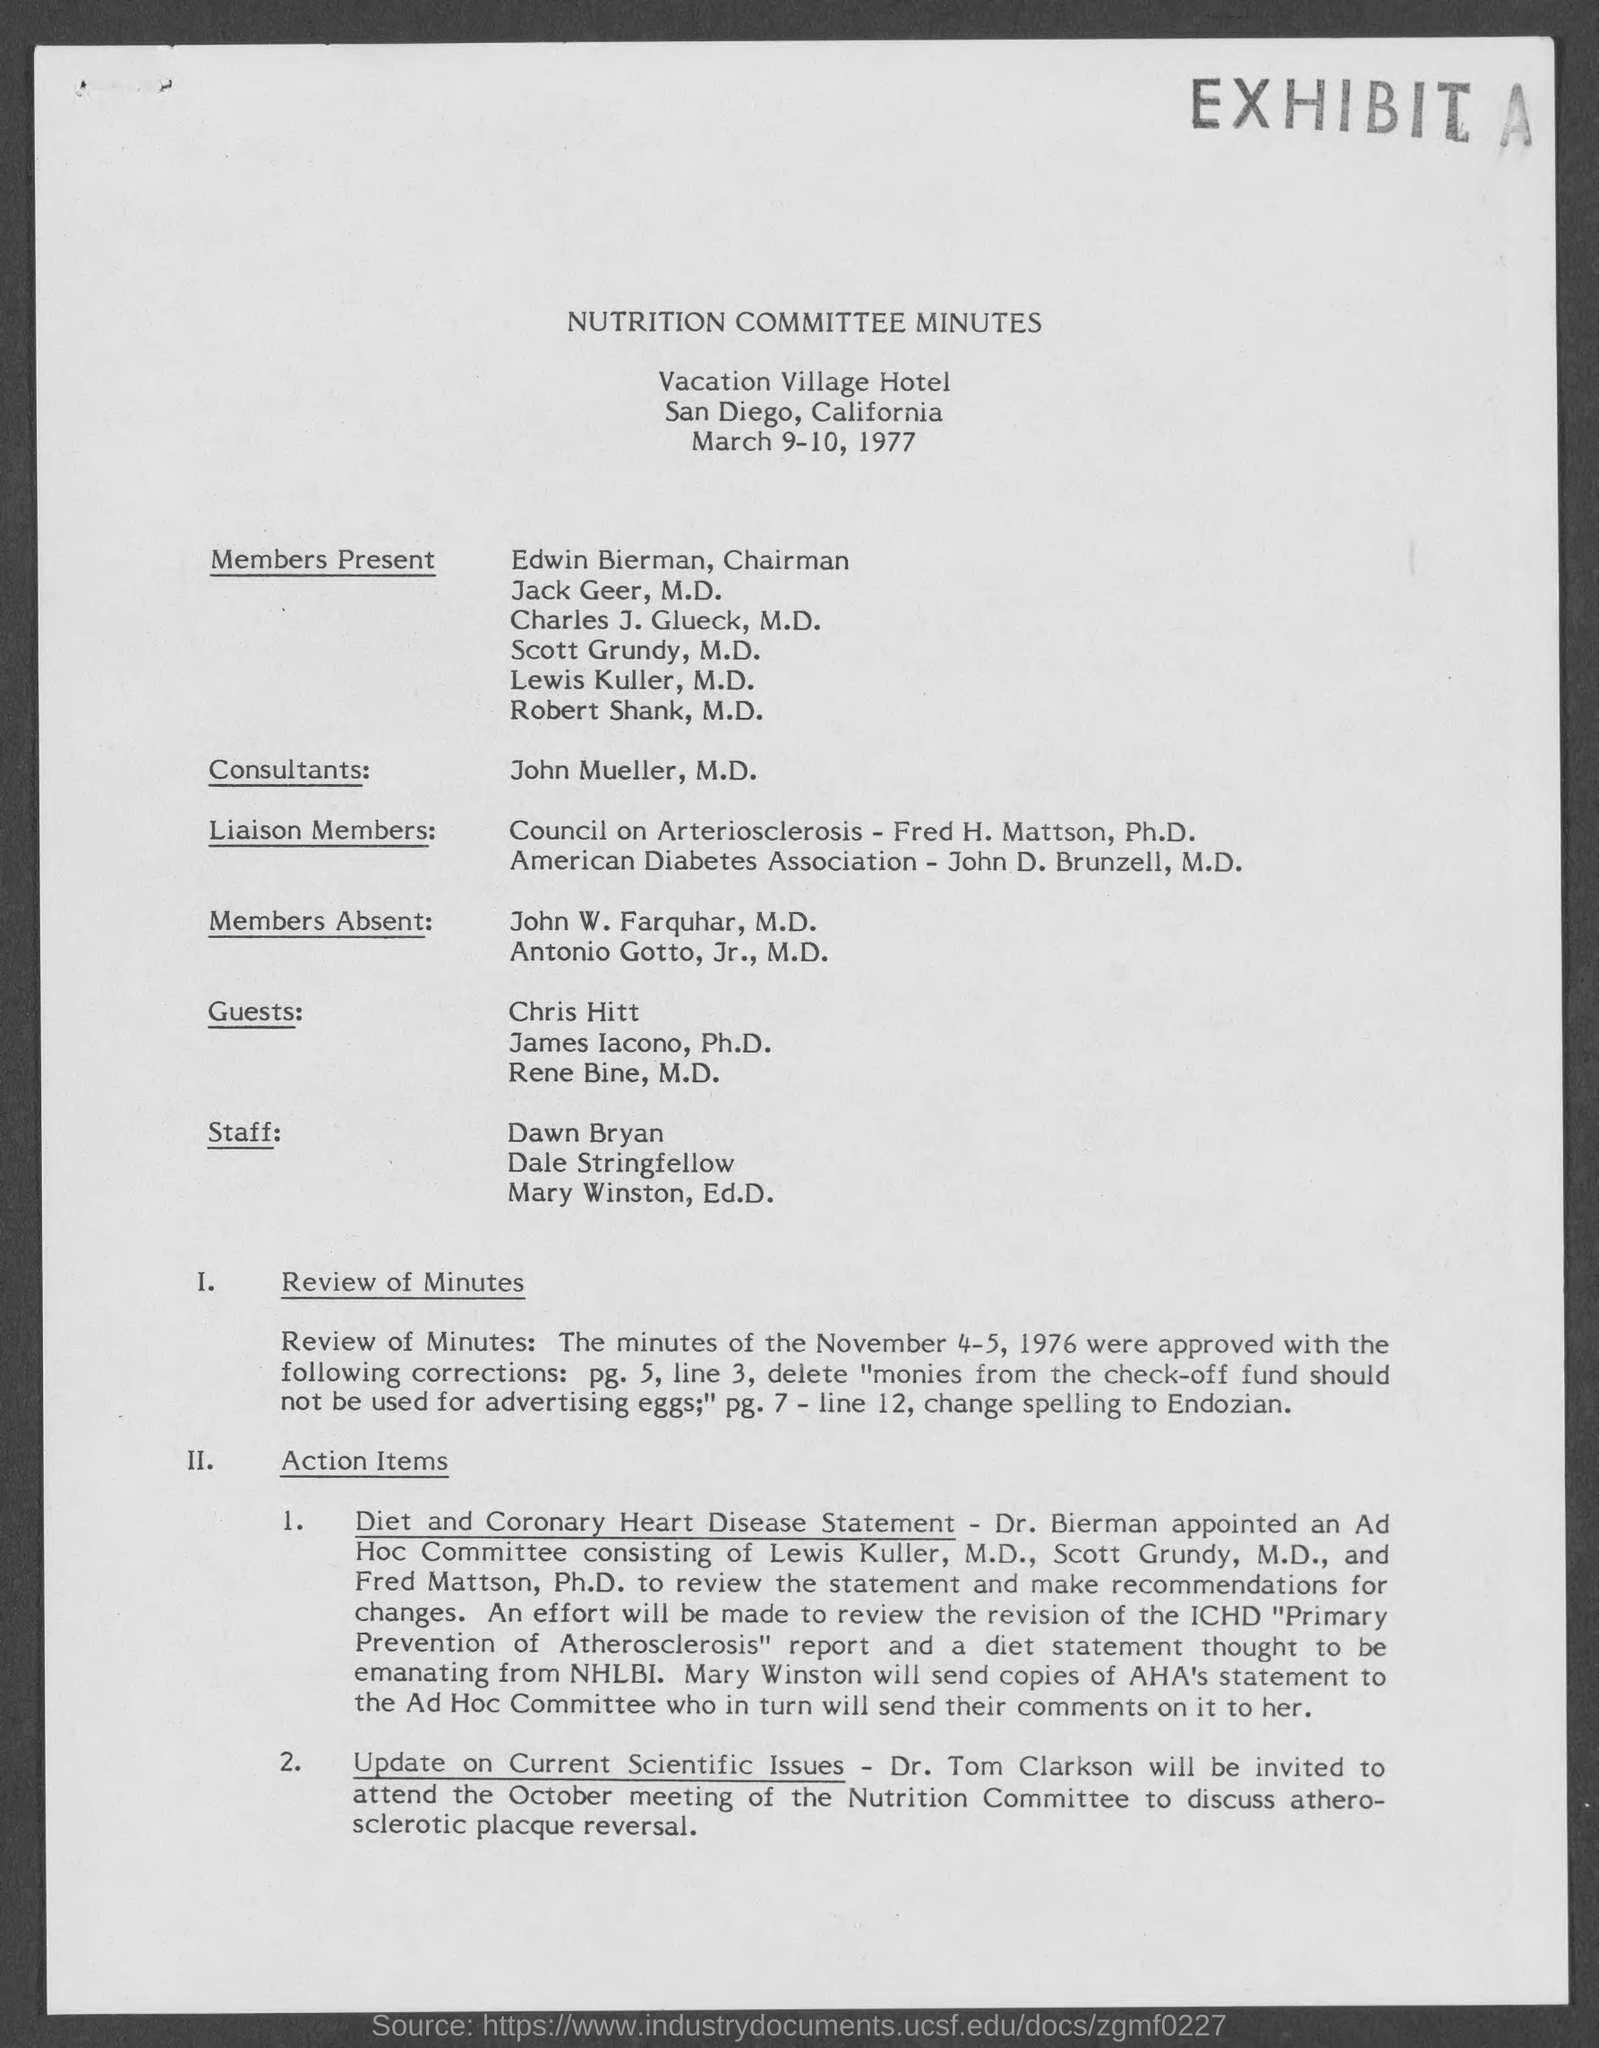What is the date?
Your answer should be very brief. March 9-10, 1977. 